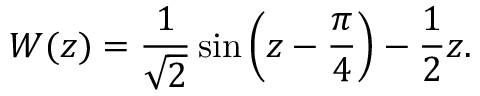<formula> <loc_0><loc_0><loc_500><loc_500>W ( z ) = \frac { 1 } { \sqrt { 2 } } \sin \left ( z - \frac { \pi } { 4 } \right ) - \frac { 1 } { 2 } z .</formula> 